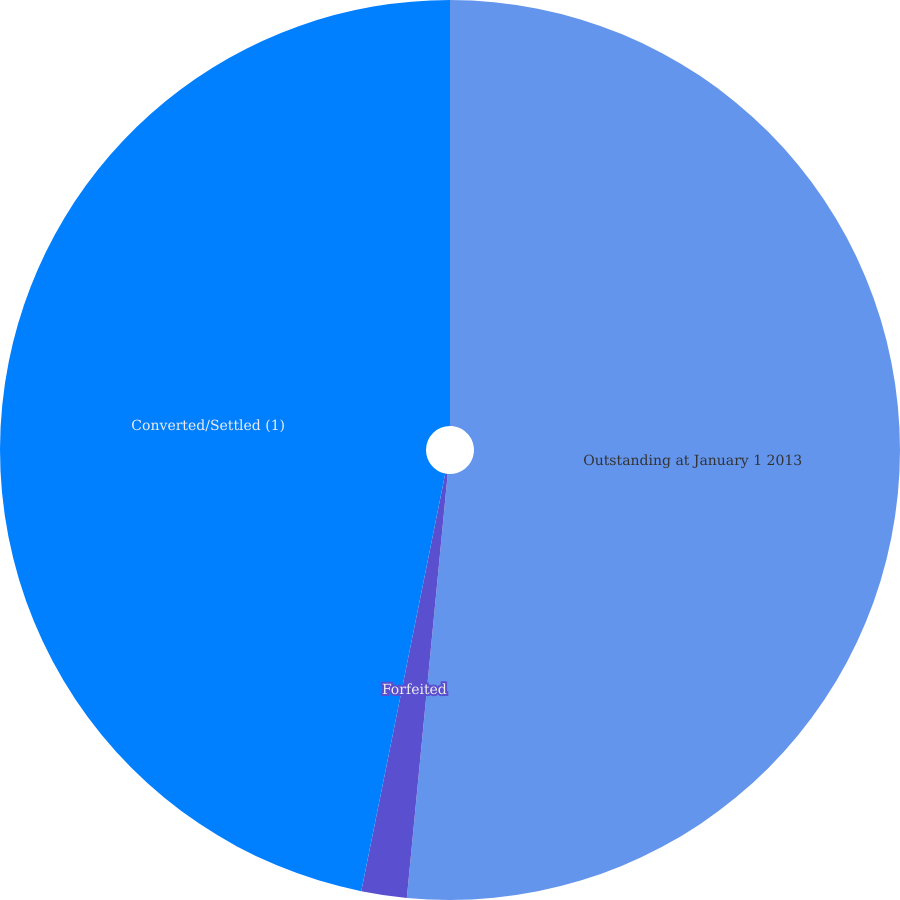Convert chart. <chart><loc_0><loc_0><loc_500><loc_500><pie_chart><fcel>Outstanding at January 1 2013<fcel>Forfeited<fcel>Converted/Settled (1)<nl><fcel>51.53%<fcel>1.63%<fcel>46.84%<nl></chart> 